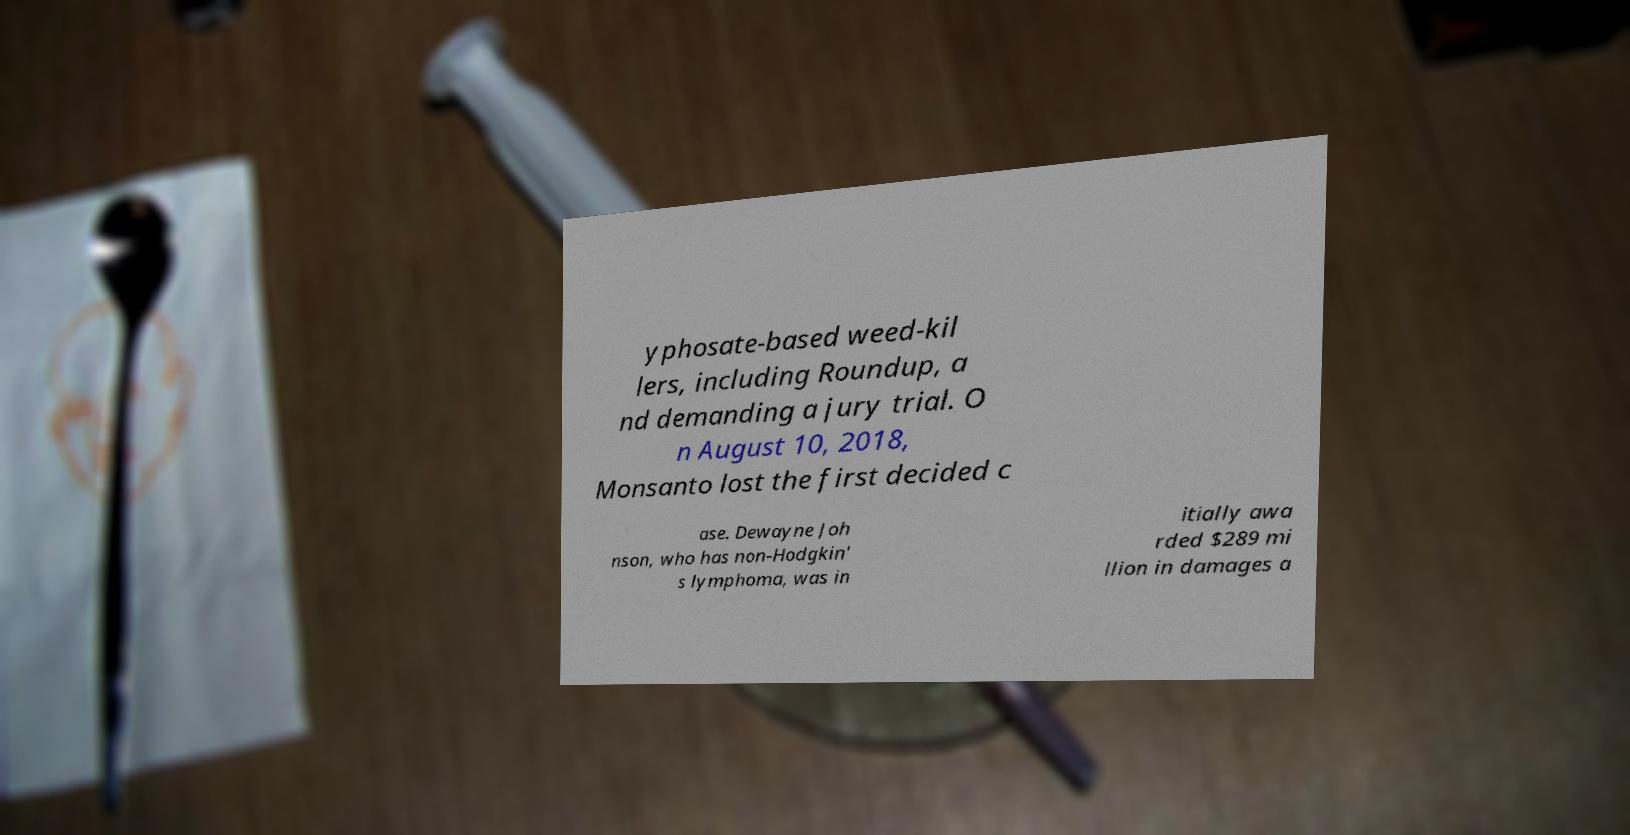Could you assist in decoding the text presented in this image and type it out clearly? yphosate-based weed-kil lers, including Roundup, a nd demanding a jury trial. O n August 10, 2018, Monsanto lost the first decided c ase. Dewayne Joh nson, who has non-Hodgkin' s lymphoma, was in itially awa rded $289 mi llion in damages a 